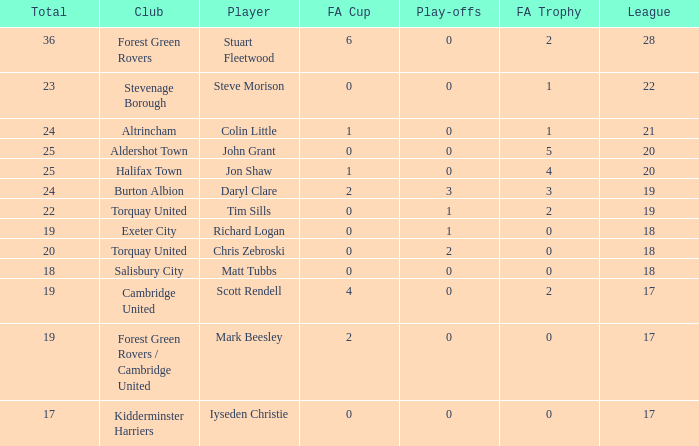Write the full table. {'header': ['Total', 'Club', 'Player', 'FA Cup', 'Play-offs', 'FA Trophy', 'League'], 'rows': [['36', 'Forest Green Rovers', 'Stuart Fleetwood', '6', '0', '2', '28'], ['23', 'Stevenage Borough', 'Steve Morison', '0', '0', '1', '22'], ['24', 'Altrincham', 'Colin Little', '1', '0', '1', '21'], ['25', 'Aldershot Town', 'John Grant', '0', '0', '5', '20'], ['25', 'Halifax Town', 'Jon Shaw', '1', '0', '4', '20'], ['24', 'Burton Albion', 'Daryl Clare', '2', '3', '3', '19'], ['22', 'Torquay United', 'Tim Sills', '0', '1', '2', '19'], ['19', 'Exeter City', 'Richard Logan', '0', '1', '0', '18'], ['20', 'Torquay United', 'Chris Zebroski', '0', '2', '0', '18'], ['18', 'Salisbury City', 'Matt Tubbs', '0', '0', '0', '18'], ['19', 'Cambridge United', 'Scott Rendell', '4', '0', '2', '17'], ['19', 'Forest Green Rovers / Cambridge United', 'Mark Beesley', '2', '0', '0', '17'], ['17', 'Kidderminster Harriers', 'Iyseden Christie', '0', '0', '0', '17']]} What mean total had a league number of 18, Richard Logan as a player, and a play-offs number smaller than 1? None. 